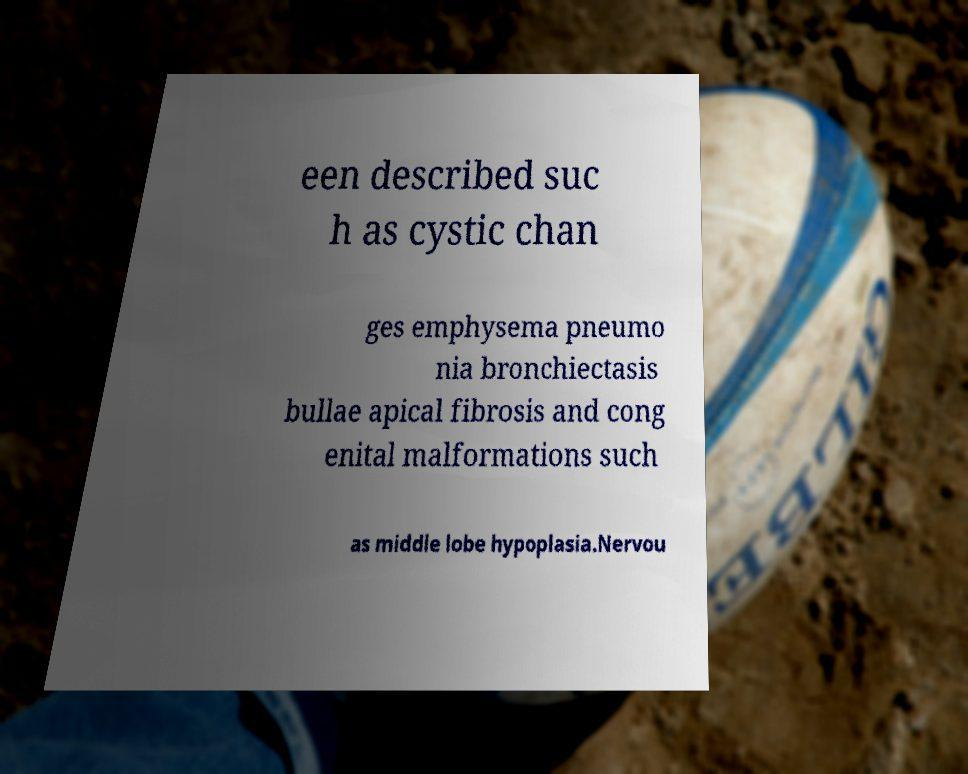Could you assist in decoding the text presented in this image and type it out clearly? een described suc h as cystic chan ges emphysema pneumo nia bronchiectasis bullae apical fibrosis and cong enital malformations such as middle lobe hypoplasia.Nervou 